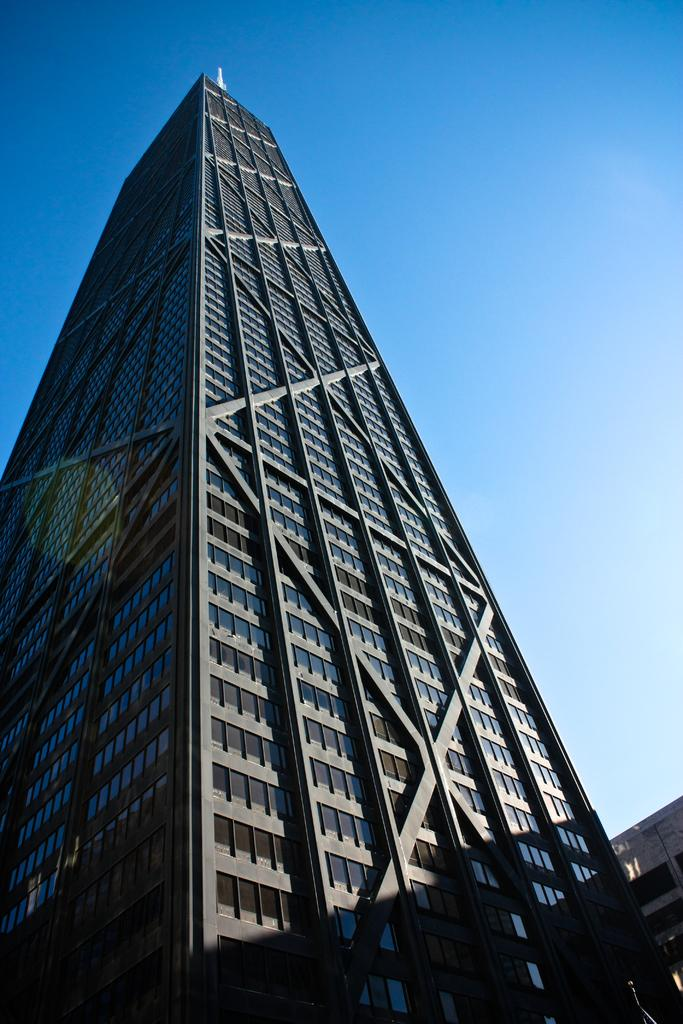What type of structures can be seen in the image? There are buildings in the image. What feature is present on the buildings? There are windows in the image. What is the color of the sky in the image? The sky is blue and white in color. Can you see any haircuts being given near the lake in the image? There is no lake or haircuts present in the image; it features buildings and a blue and white sky. Is there a turkey visible in the image? There is no turkey present in the image. 